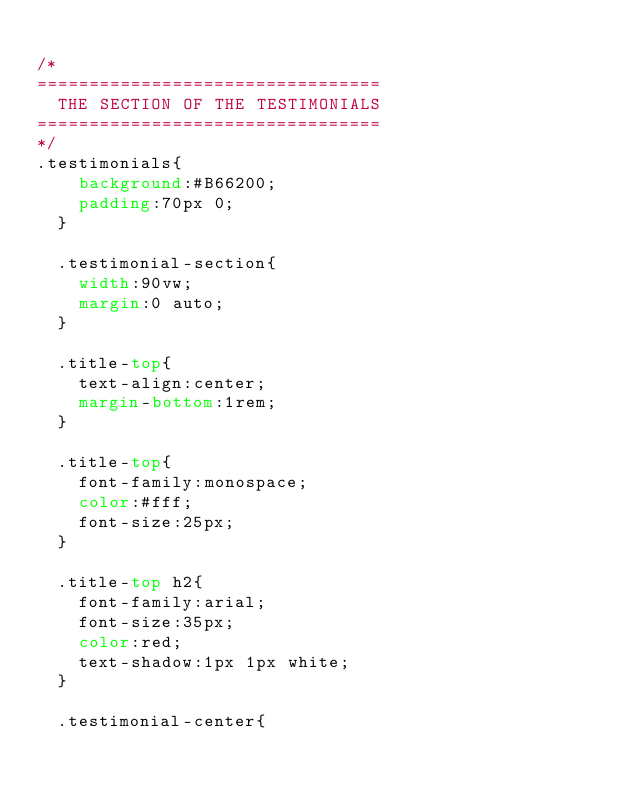<code> <loc_0><loc_0><loc_500><loc_500><_CSS_>
/* 
=================================
  THE SECTION OF THE TESTIMONIALS
=================================
*/
.testimonials{
    background:#B66200;
    padding:70px 0;
  }
  
  .testimonial-section{
    width:90vw;
    margin:0 auto;
  }
  
  .title-top{
    text-align:center;
    margin-bottom:1rem;
  }
  
  .title-top{
    font-family:monospace;
    color:#fff;
    font-size:25px;
  }
  
  .title-top h2{
    font-family:arial;
    font-size:35px;
    color:red;
    text-shadow:1px 1px white;
  }
  
  .testimonial-center{</code> 